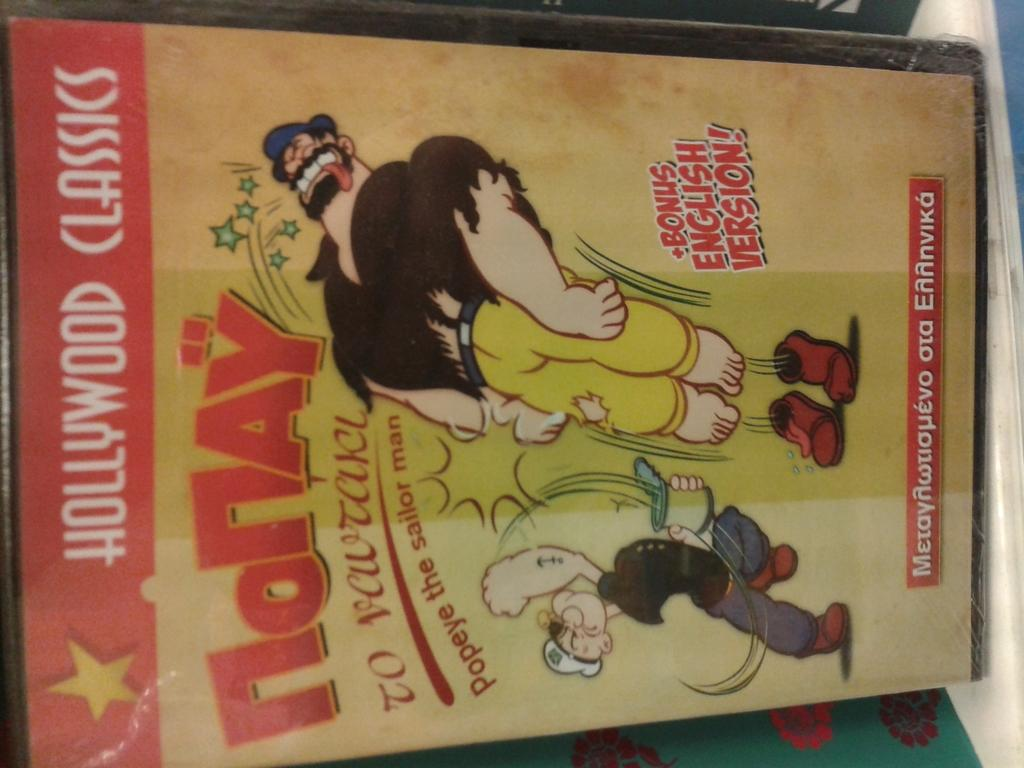<image>
Render a clear and concise summary of the photo. Popeye is visible on the front cover of a Hollywood Classics book. 